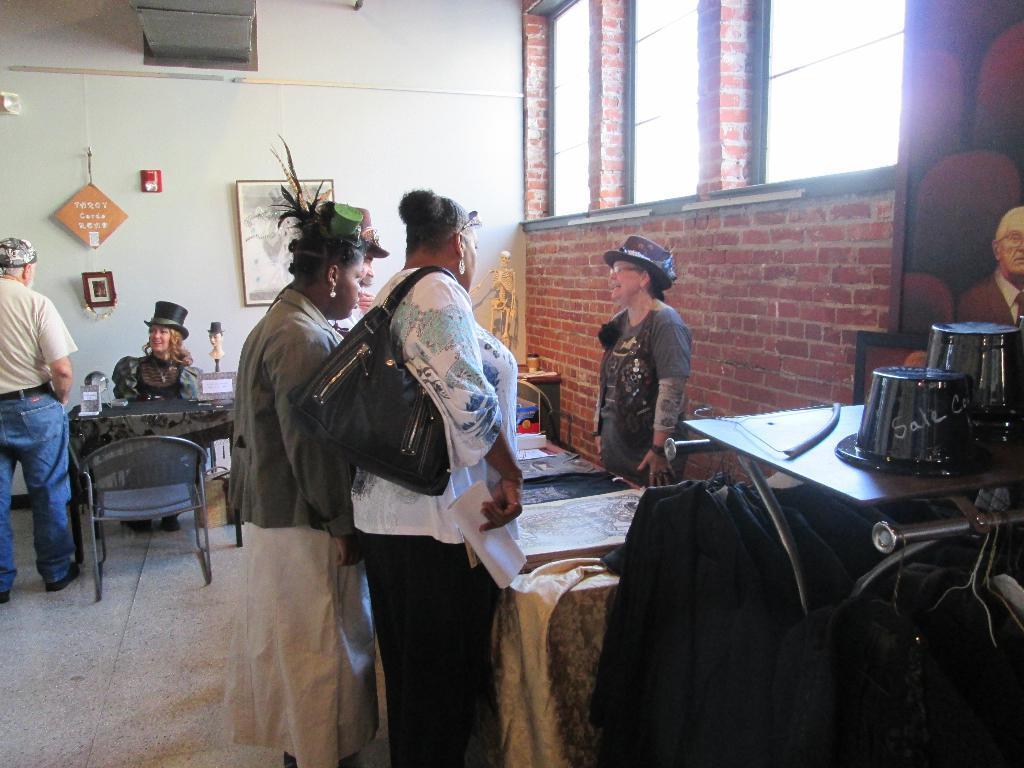Describe this image in one or two sentences. In this image their is a woman to the left side is sitting on chair and talking with another man and to the right side we have woman standing and explaining to the other three people. In the middle there is a woman who is holding a bag and a paper in her hand. At the background their is a wall with a photo frame and to the right side their is a brick wall with a windows attached to it. The woman who is standing at the right side is having a cap and spectacles. There is a skeleton in the wall. To the left side their is a table on which there are toy,glass,on the right side their is a hangers and a stand. 